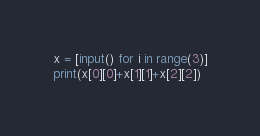<code> <loc_0><loc_0><loc_500><loc_500><_Python_>x = [input() for i in range(3)]
print(x[0][0]+x[1][1]+x[2][2])</code> 